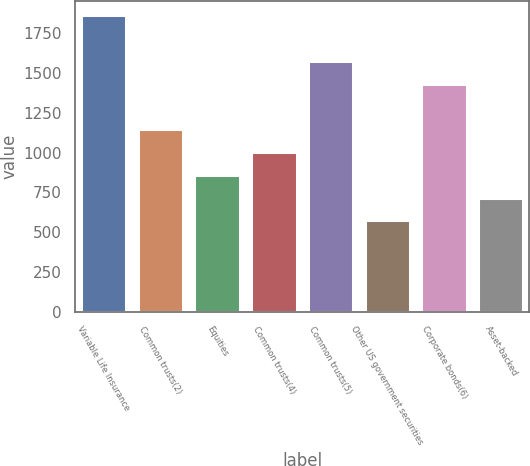<chart> <loc_0><loc_0><loc_500><loc_500><bar_chart><fcel>Variable Life Insurance<fcel>Common trusts(2)<fcel>Equities<fcel>Common trusts(4)<fcel>Common trusts(5)<fcel>Other US government securities<fcel>Corporate bonds(6)<fcel>Asset-backed<nl><fcel>1861.3<fcel>1145.8<fcel>859.6<fcel>1002.7<fcel>1575.1<fcel>573.4<fcel>1432<fcel>716.5<nl></chart> 